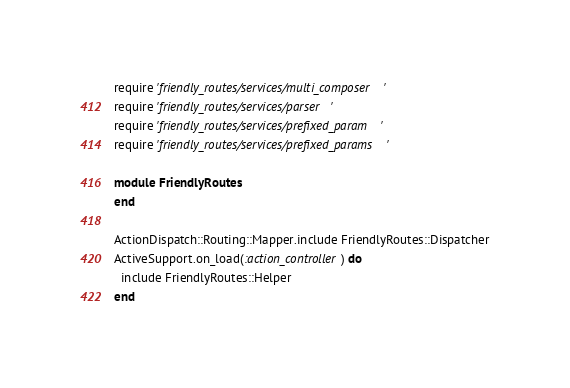<code> <loc_0><loc_0><loc_500><loc_500><_Ruby_>require 'friendly_routes/services/multi_composer'
require 'friendly_routes/services/parser'
require 'friendly_routes/services/prefixed_param'
require 'friendly_routes/services/prefixed_params'

module FriendlyRoutes
end

ActionDispatch::Routing::Mapper.include FriendlyRoutes::Dispatcher
ActiveSupport.on_load(:action_controller) do
  include FriendlyRoutes::Helper
end
</code> 